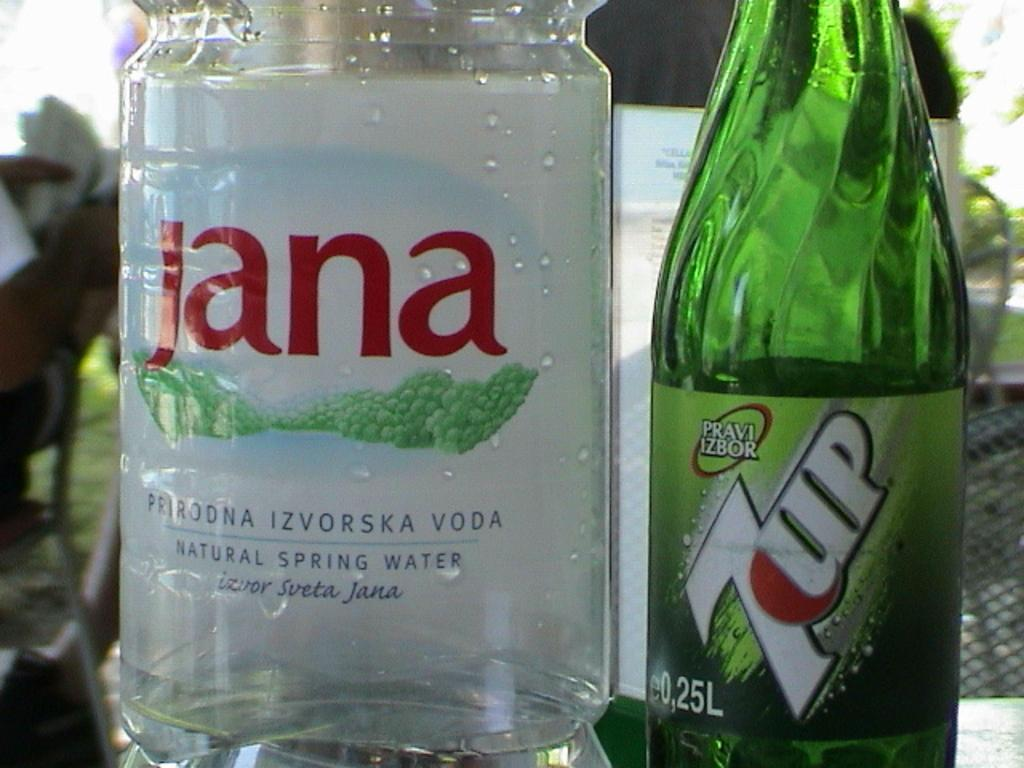<image>
Provide a brief description of the given image. A bottle of 7up is next to a bottle of vodka. 